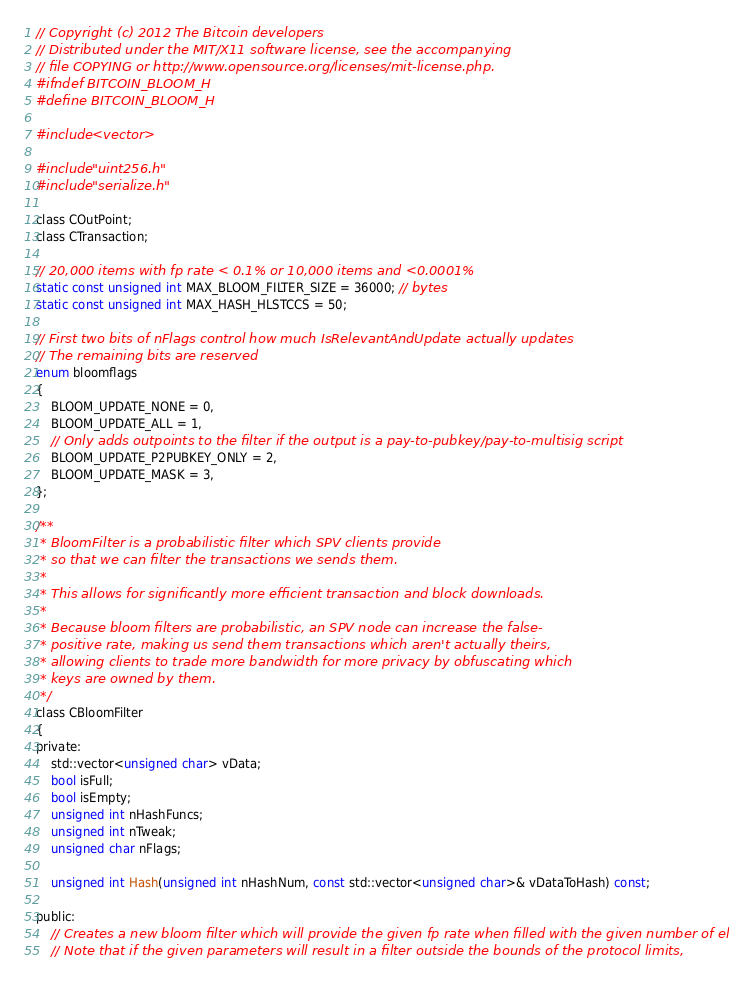Convert code to text. <code><loc_0><loc_0><loc_500><loc_500><_C_>// Copyright (c) 2012 The Bitcoin developers
// Distributed under the MIT/X11 software license, see the accompanying
// file COPYING or http://www.opensource.org/licenses/mit-license.php.
#ifndef BITCOIN_BLOOM_H
#define BITCOIN_BLOOM_H

#include <vector>

#include "uint256.h"
#include "serialize.h"

class COutPoint;
class CTransaction;

// 20,000 items with fp rate < 0.1% or 10,000 items and <0.0001%
static const unsigned int MAX_BLOOM_FILTER_SIZE = 36000; // bytes
static const unsigned int MAX_HASH_HLSTCCS = 50;

// First two bits of nFlags control how much IsRelevantAndUpdate actually updates
// The remaining bits are reserved
enum bloomflags
{
    BLOOM_UPDATE_NONE = 0,
    BLOOM_UPDATE_ALL = 1,
    // Only adds outpoints to the filter if the output is a pay-to-pubkey/pay-to-multisig script
    BLOOM_UPDATE_P2PUBKEY_ONLY = 2,
    BLOOM_UPDATE_MASK = 3,
};

/**
 * BloomFilter is a probabilistic filter which SPV clients provide
 * so that we can filter the transactions we sends them.
 * 
 * This allows for significantly more efficient transaction and block downloads.
 * 
 * Because bloom filters are probabilistic, an SPV node can increase the false-
 * positive rate, making us send them transactions which aren't actually theirs, 
 * allowing clients to trade more bandwidth for more privacy by obfuscating which
 * keys are owned by them.
 */
class CBloomFilter
{
private:
    std::vector<unsigned char> vData;
    bool isFull;
    bool isEmpty;
    unsigned int nHashFuncs;
    unsigned int nTweak;
    unsigned char nFlags;

    unsigned int Hash(unsigned int nHashNum, const std::vector<unsigned char>& vDataToHash) const;

public:
    // Creates a new bloom filter which will provide the given fp rate when filled with the given number of elements
    // Note that if the given parameters will result in a filter outside the bounds of the protocol limits,</code> 